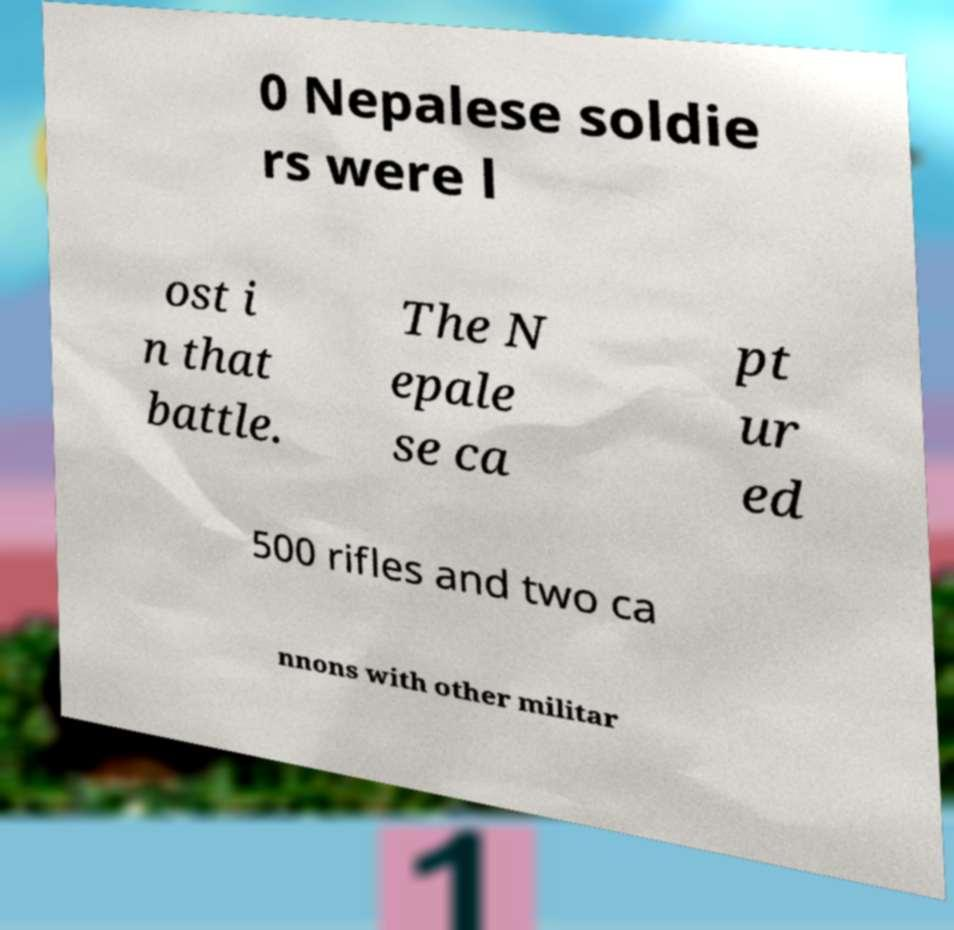There's text embedded in this image that I need extracted. Can you transcribe it verbatim? 0 Nepalese soldie rs were l ost i n that battle. The N epale se ca pt ur ed 500 rifles and two ca nnons with other militar 